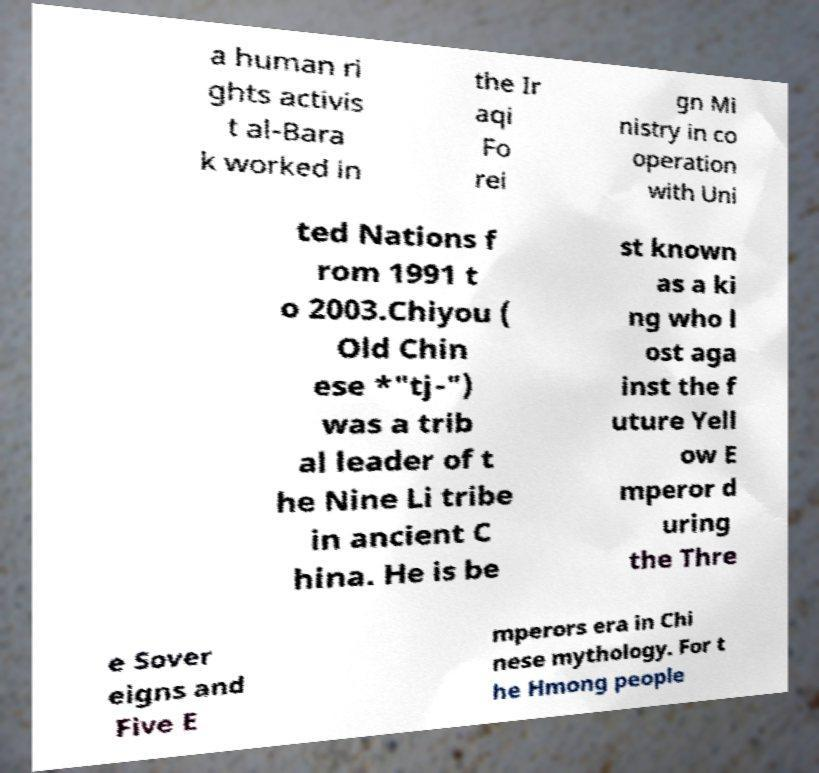Please identify and transcribe the text found in this image. a human ri ghts activis t al-Bara k worked in the Ir aqi Fo rei gn Mi nistry in co operation with Uni ted Nations f rom 1991 t o 2003.Chiyou ( Old Chin ese *"tj-") was a trib al leader of t he Nine Li tribe in ancient C hina. He is be st known as a ki ng who l ost aga inst the f uture Yell ow E mperor d uring the Thre e Sover eigns and Five E mperors era in Chi nese mythology. For t he Hmong people 